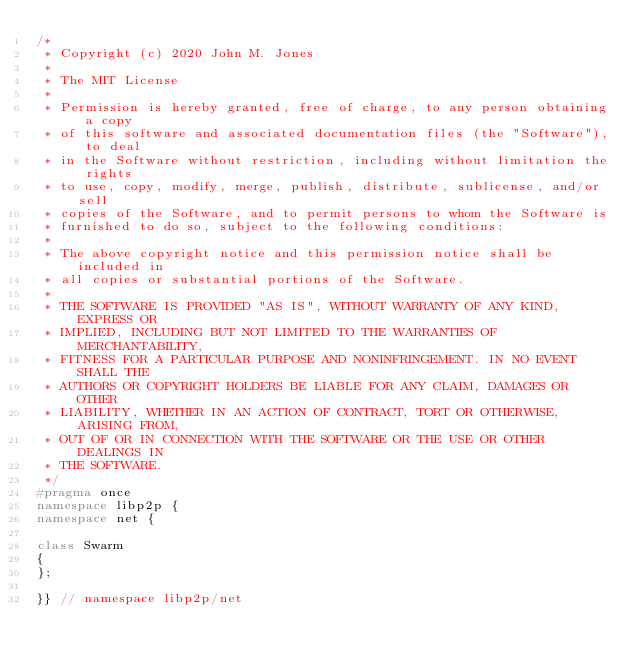<code> <loc_0><loc_0><loc_500><loc_500><_C++_>/*
 * Copyright (c) 2020 John M. Jones
 *
 * The MIT License
 *
 * Permission is hereby granted, free of charge, to any person obtaining a copy
 * of this software and associated documentation files (the "Software"), to deal
 * in the Software without restriction, including without limitation the rights
 * to use, copy, modify, merge, publish, distribute, sublicense, and/or sell
 * copies of the Software, and to permit persons to whom the Software is
 * furnished to do so, subject to the following conditions:
 *
 * The above copyright notice and this permission notice shall be included in
 * all copies or substantial portions of the Software.
 *
 * THE SOFTWARE IS PROVIDED "AS IS", WITHOUT WARRANTY OF ANY KIND, EXPRESS OR
 * IMPLIED, INCLUDING BUT NOT LIMITED TO THE WARRANTIES OF MERCHANTABILITY,
 * FITNESS FOR A PARTICULAR PURPOSE AND NONINFRINGEMENT. IN NO EVENT SHALL THE
 * AUTHORS OR COPYRIGHT HOLDERS BE LIABLE FOR ANY CLAIM, DAMAGES OR OTHER
 * LIABILITY, WHETHER IN AN ACTION OF CONTRACT, TORT OR OTHERWISE, ARISING FROM,
 * OUT OF OR IN CONNECTION WITH THE SOFTWARE OR THE USE OR OTHER DEALINGS IN
 * THE SOFTWARE.
 */
#pragma once
namespace libp2p {
namespace net {

class Swarm
{
};

}} // namespace libp2p/net</code> 